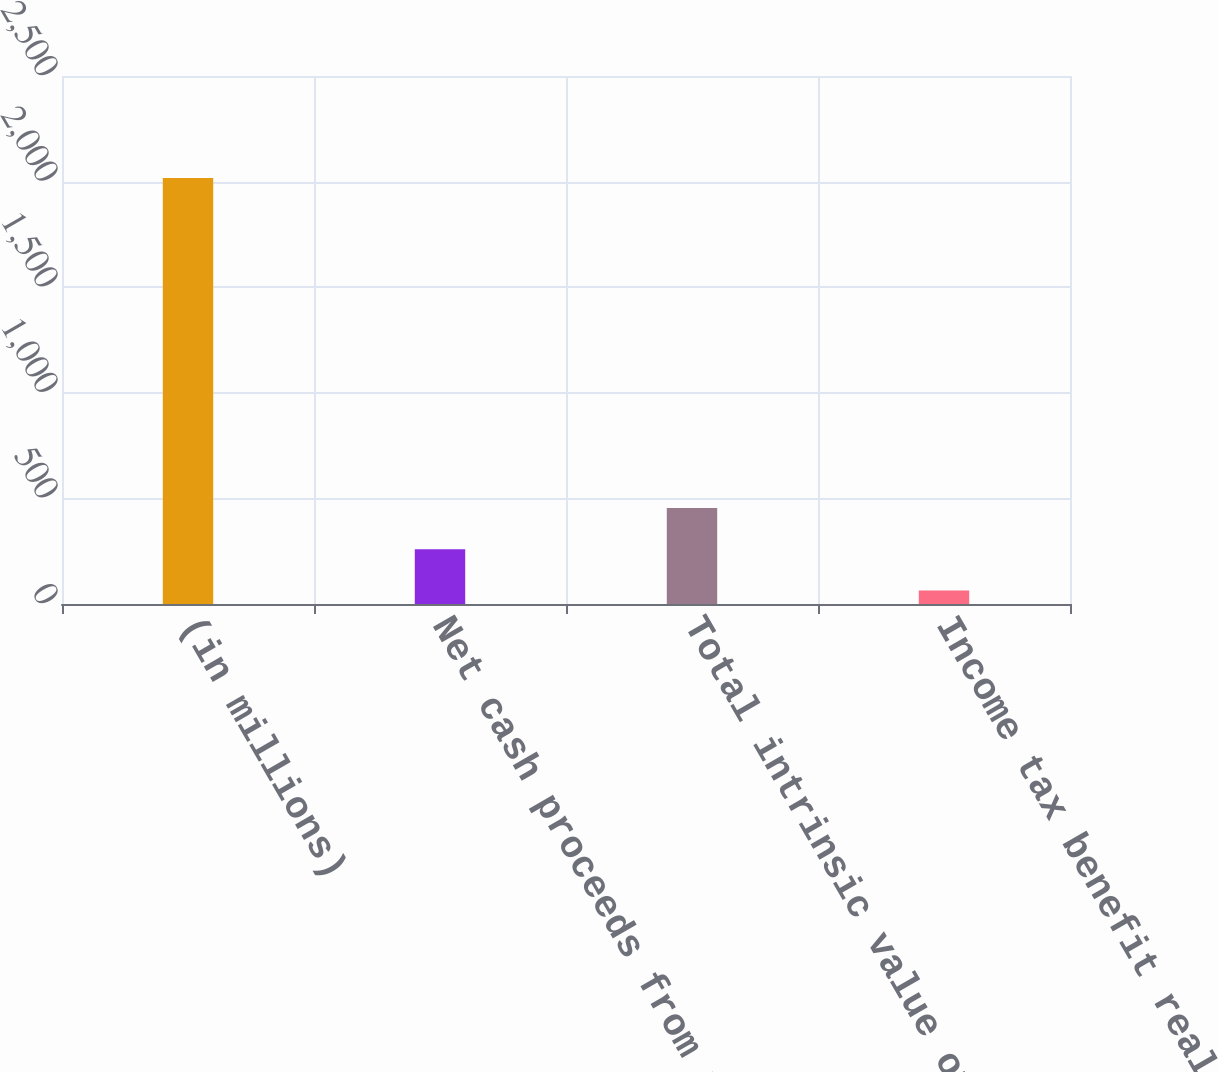Convert chart. <chart><loc_0><loc_0><loc_500><loc_500><bar_chart><fcel>(in millions)<fcel>Net cash proceeds from the<fcel>Total intrinsic value of stock<fcel>Income tax benefit realized<nl><fcel>2017<fcel>259.3<fcel>454.6<fcel>64<nl></chart> 